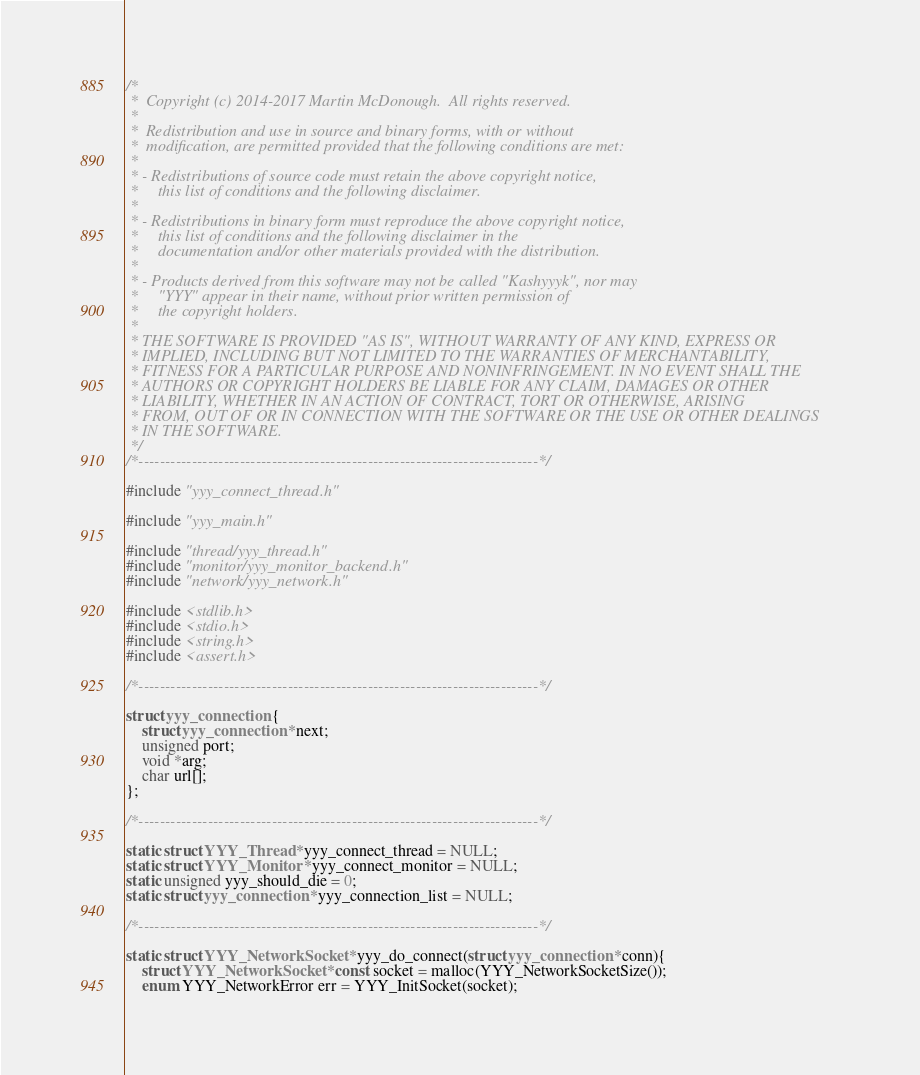Convert code to text. <code><loc_0><loc_0><loc_500><loc_500><_C_>/* 
 *  Copyright (c) 2014-2017 Martin McDonough.  All rights reserved.
 * 
 *  Redistribution and use in source and binary forms, with or without
 *  modification, are permitted provided that the following conditions are met:
 * 
 * - Redistributions of source code must retain the above copyright notice,
 *     this list of conditions and the following disclaimer.
 * 
 * - Redistributions in binary form must reproduce the above copyright notice,
 *     this list of conditions and the following disclaimer in the
 *     documentation and/or other materials provided with the distribution.
 * 
 * - Products derived from this software may not be called "Kashyyyk", nor may
 *     "YYY" appear in their name, without prior written permission of
 *     the copyright holders.
 * 
 * THE SOFTWARE IS PROVIDED "AS IS", WITHOUT WARRANTY OF ANY KIND, EXPRESS OR
 * IMPLIED, INCLUDING BUT NOT LIMITED TO THE WARRANTIES OF MERCHANTABILITY,
 * FITNESS FOR A PARTICULAR PURPOSE AND NONINFRINGEMENT. IN NO EVENT SHALL THE
 * AUTHORS OR COPYRIGHT HOLDERS BE LIABLE FOR ANY CLAIM, DAMAGES OR OTHER
 * LIABILITY, WHETHER IN AN ACTION OF CONTRACT, TORT OR OTHERWISE, ARISING
 * FROM, OUT OF OR IN CONNECTION WITH THE SOFTWARE OR THE USE OR OTHER DEALINGS
 * IN THE SOFTWARE.
 */
/*---------------------------------------------------------------------------*/

#include "yyy_connect_thread.h"

#include "yyy_main.h"

#include "thread/yyy_thread.h"
#include "monitor/yyy_monitor_backend.h"
#include "network/yyy_network.h"

#include <stdlib.h>
#include <stdio.h>
#include <string.h>
#include <assert.h>

/*---------------------------------------------------------------------------*/

struct yyy_connection {
    struct yyy_connection *next;
    unsigned port;
    void *arg;
    char url[];
};

/*---------------------------------------------------------------------------*/

static struct YYY_Thread *yyy_connect_thread = NULL;
static struct YYY_Monitor *yyy_connect_monitor = NULL;
static unsigned yyy_should_die = 0;
static struct yyy_connection *yyy_connection_list = NULL;

/*---------------------------------------------------------------------------*/

static struct YYY_NetworkSocket *yyy_do_connect(struct yyy_connection *conn){
    struct YYY_NetworkSocket *const socket = malloc(YYY_NetworkSocketSize());
    enum YYY_NetworkError err = YYY_InitSocket(socket);</code> 